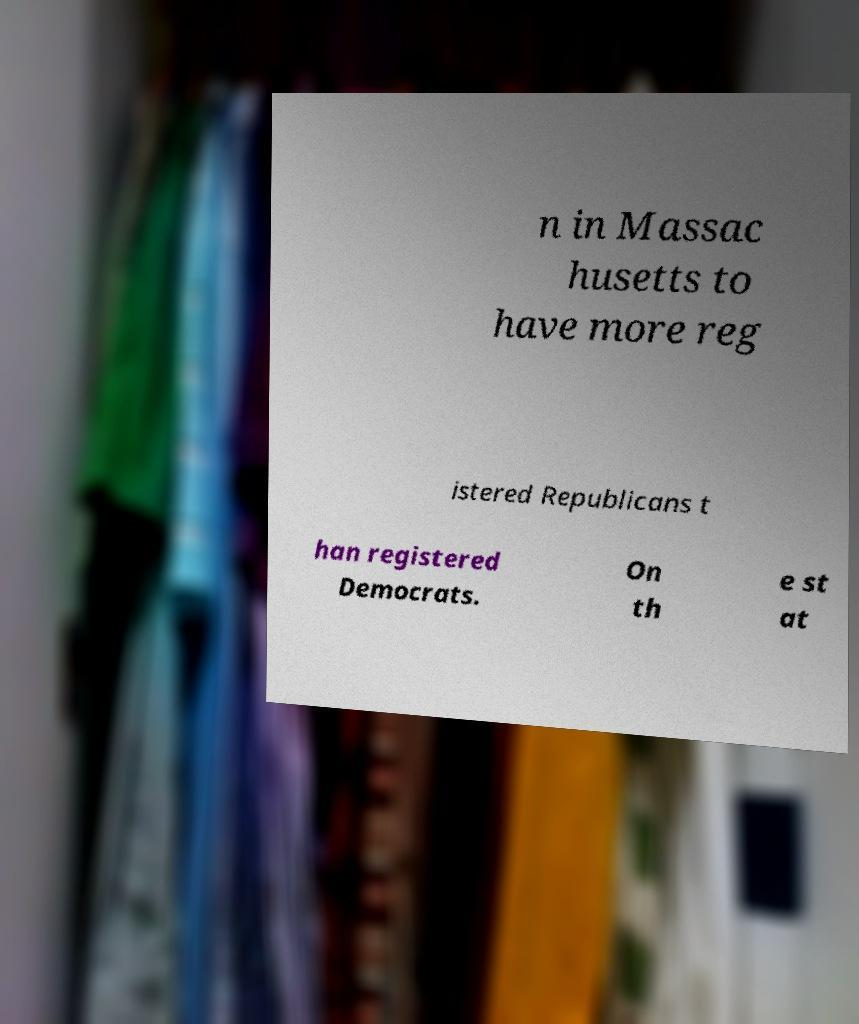I need the written content from this picture converted into text. Can you do that? n in Massac husetts to have more reg istered Republicans t han registered Democrats. On th e st at 